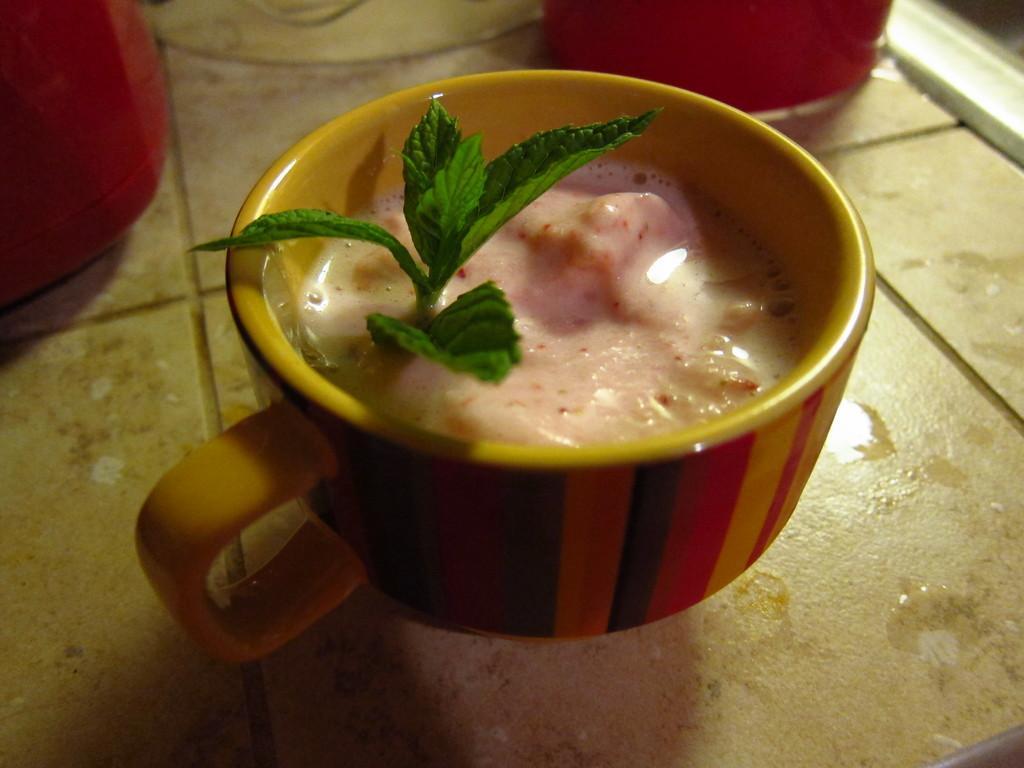Describe this image in one or two sentences. In this image we can see drink and leaves in a cup, there are two red colored objects, these are on the tiles. 